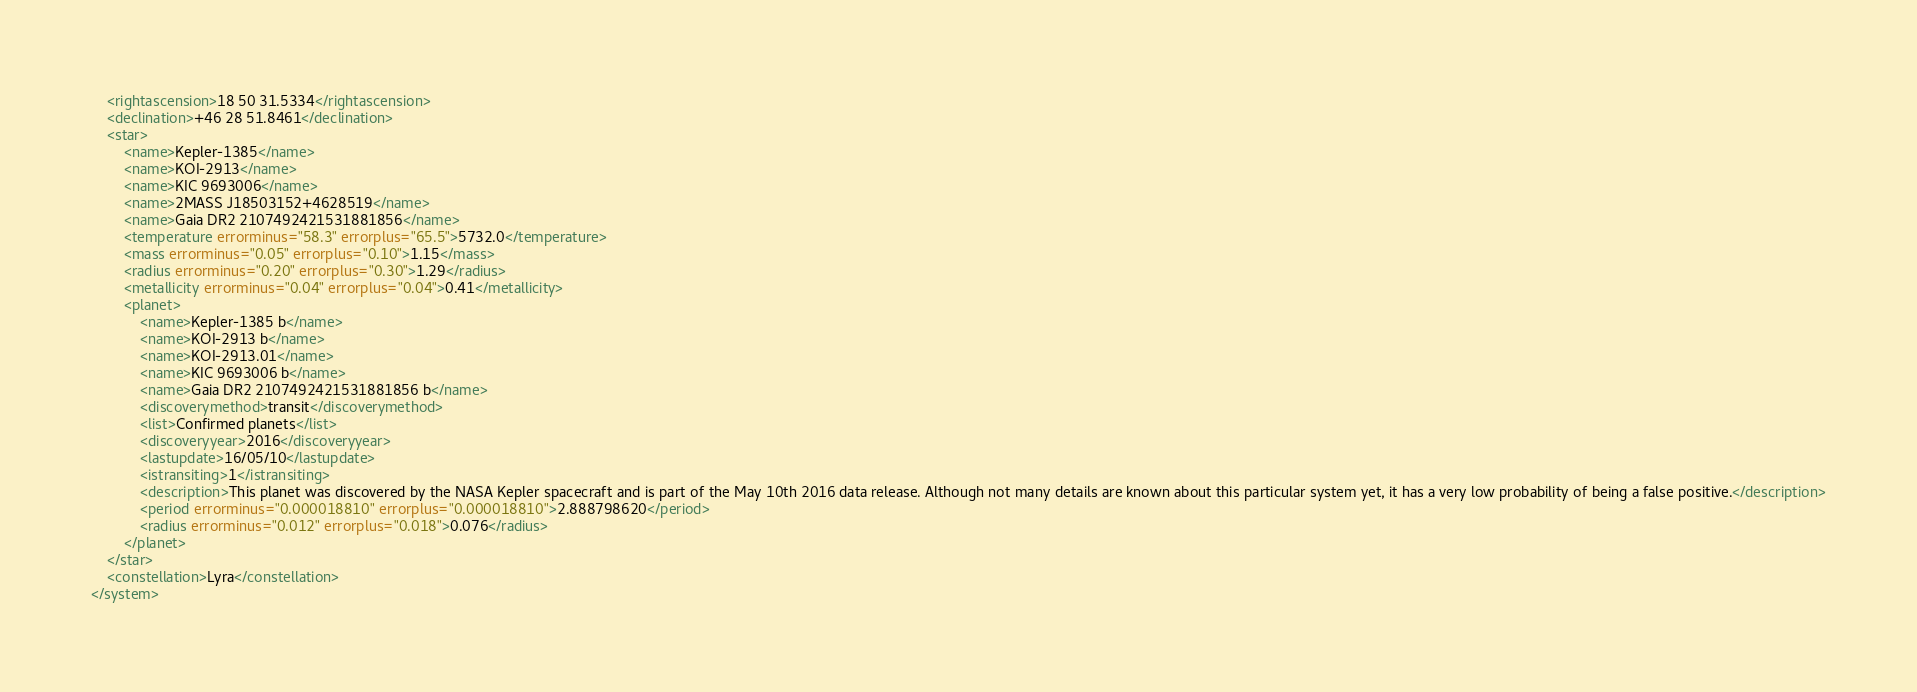<code> <loc_0><loc_0><loc_500><loc_500><_XML_>	<rightascension>18 50 31.5334</rightascension>
	<declination>+46 28 51.8461</declination>
	<star>
		<name>Kepler-1385</name>
		<name>KOI-2913</name>
		<name>KIC 9693006</name>
		<name>2MASS J18503152+4628519</name>
		<name>Gaia DR2 2107492421531881856</name>
		<temperature errorminus="58.3" errorplus="65.5">5732.0</temperature>
		<mass errorminus="0.05" errorplus="0.10">1.15</mass>
		<radius errorminus="0.20" errorplus="0.30">1.29</radius>
		<metallicity errorminus="0.04" errorplus="0.04">0.41</metallicity>
		<planet>
			<name>Kepler-1385 b</name>
			<name>KOI-2913 b</name>
			<name>KOI-2913.01</name>
			<name>KIC 9693006 b</name>
			<name>Gaia DR2 2107492421531881856 b</name>
			<discoverymethod>transit</discoverymethod>
			<list>Confirmed planets</list>
			<discoveryyear>2016</discoveryyear>
			<lastupdate>16/05/10</lastupdate>
			<istransiting>1</istransiting>
			<description>This planet was discovered by the NASA Kepler spacecraft and is part of the May 10th 2016 data release. Although not many details are known about this particular system yet, it has a very low probability of being a false positive.</description>
			<period errorminus="0.000018810" errorplus="0.000018810">2.888798620</period>
			<radius errorminus="0.012" errorplus="0.018">0.076</radius>
		</planet>
	</star>
	<constellation>Lyra</constellation>
</system>
</code> 